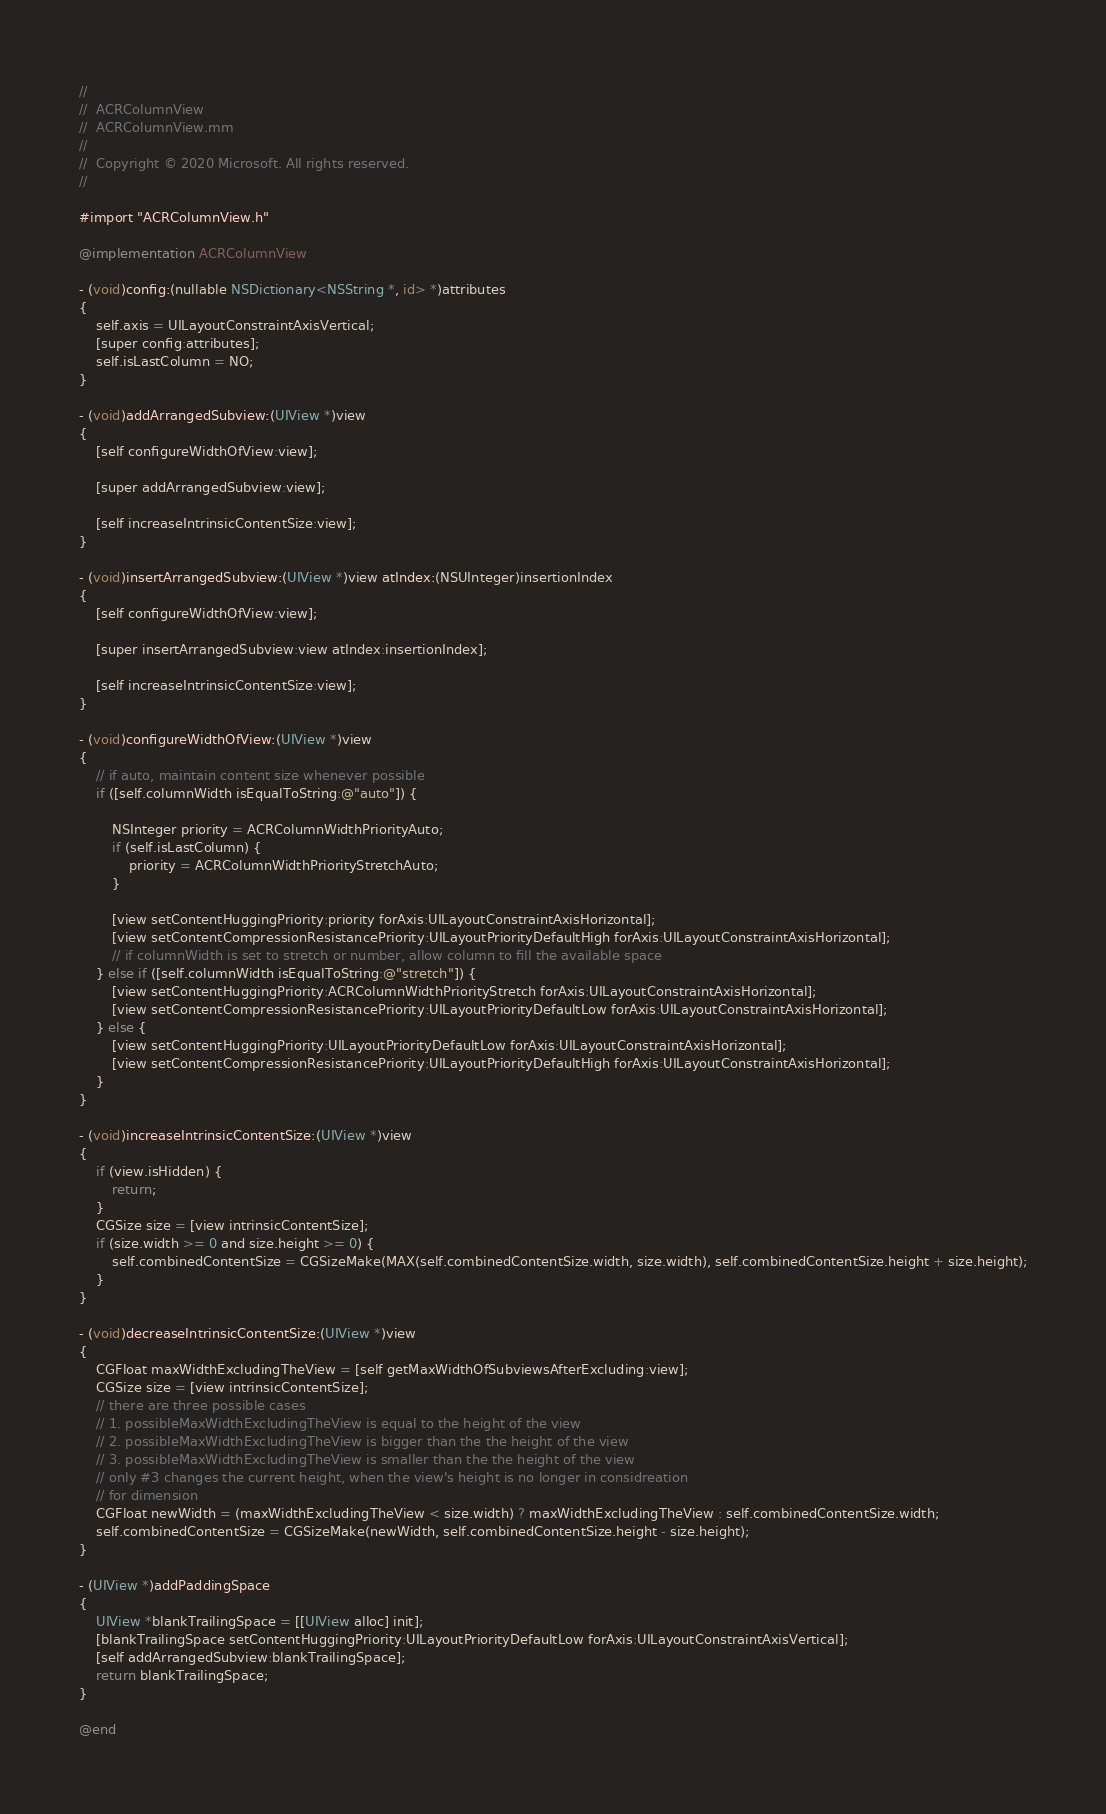<code> <loc_0><loc_0><loc_500><loc_500><_ObjectiveC_>//
//  ACRColumnView
//  ACRColumnView.mm
//
//  Copyright © 2020 Microsoft. All rights reserved.
//

#import "ACRColumnView.h"

@implementation ACRColumnView

- (void)config:(nullable NSDictionary<NSString *, id> *)attributes
{
    self.axis = UILayoutConstraintAxisVertical;
    [super config:attributes];
    self.isLastColumn = NO;
}

- (void)addArrangedSubview:(UIView *)view
{
    [self configureWidthOfView:view];

    [super addArrangedSubview:view];

    [self increaseIntrinsicContentSize:view];
}

- (void)insertArrangedSubview:(UIView *)view atIndex:(NSUInteger)insertionIndex
{
    [self configureWidthOfView:view];

    [super insertArrangedSubview:view atIndex:insertionIndex];

    [self increaseIntrinsicContentSize:view];
}

- (void)configureWidthOfView:(UIView *)view
{
    // if auto, maintain content size whenever possible
    if ([self.columnWidth isEqualToString:@"auto"]) {

        NSInteger priority = ACRColumnWidthPriorityAuto;
        if (self.isLastColumn) {
            priority = ACRColumnWidthPriorityStretchAuto;
        }

        [view setContentHuggingPriority:priority forAxis:UILayoutConstraintAxisHorizontal];
        [view setContentCompressionResistancePriority:UILayoutPriorityDefaultHigh forAxis:UILayoutConstraintAxisHorizontal];
        // if columnWidth is set to stretch or number, allow column to fill the available space
    } else if ([self.columnWidth isEqualToString:@"stretch"]) {
        [view setContentHuggingPriority:ACRColumnWidthPriorityStretch forAxis:UILayoutConstraintAxisHorizontal];
        [view setContentCompressionResistancePriority:UILayoutPriorityDefaultLow forAxis:UILayoutConstraintAxisHorizontal];
    } else {
        [view setContentHuggingPriority:UILayoutPriorityDefaultLow forAxis:UILayoutConstraintAxisHorizontal];
        [view setContentCompressionResistancePriority:UILayoutPriorityDefaultHigh forAxis:UILayoutConstraintAxisHorizontal];
    }
}

- (void)increaseIntrinsicContentSize:(UIView *)view
{
    if (view.isHidden) {
        return;
    }
    CGSize size = [view intrinsicContentSize];
    if (size.width >= 0 and size.height >= 0) {
        self.combinedContentSize = CGSizeMake(MAX(self.combinedContentSize.width, size.width), self.combinedContentSize.height + size.height);
    }
}

- (void)decreaseIntrinsicContentSize:(UIView *)view
{
    CGFloat maxWidthExcludingTheView = [self getMaxWidthOfSubviewsAfterExcluding:view];
    CGSize size = [view intrinsicContentSize];
    // there are three possible cases
    // 1. possibleMaxWidthExcludingTheView is equal to the height of the view
    // 2. possibleMaxWidthExcludingTheView is bigger than the the height of the view
    // 3. possibleMaxWidthExcludingTheView is smaller than the the height of the view
    // only #3 changes the current height, when the view's height is no longer in considreation
    // for dimension
    CGFloat newWidth = (maxWidthExcludingTheView < size.width) ? maxWidthExcludingTheView : self.combinedContentSize.width;
    self.combinedContentSize = CGSizeMake(newWidth, self.combinedContentSize.height - size.height);
}

- (UIView *)addPaddingSpace
{
    UIView *blankTrailingSpace = [[UIView alloc] init];
    [blankTrailingSpace setContentHuggingPriority:UILayoutPriorityDefaultLow forAxis:UILayoutConstraintAxisVertical];
    [self addArrangedSubview:blankTrailingSpace];
    return blankTrailingSpace;
}

@end
</code> 